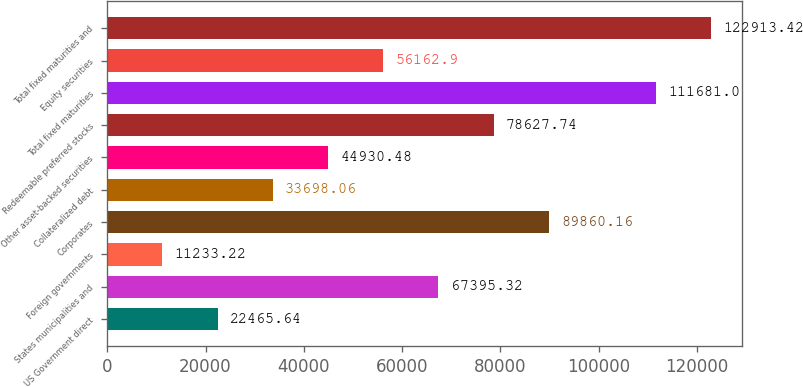<chart> <loc_0><loc_0><loc_500><loc_500><bar_chart><fcel>US Government direct<fcel>States municipalities and<fcel>Foreign governments<fcel>Corporates<fcel>Collateralized debt<fcel>Other asset-backed securities<fcel>Redeemable preferred stocks<fcel>Total fixed maturities<fcel>Equity securities<fcel>Total fixed maturities and<nl><fcel>22465.6<fcel>67395.3<fcel>11233.2<fcel>89860.2<fcel>33698.1<fcel>44930.5<fcel>78627.7<fcel>111681<fcel>56162.9<fcel>122913<nl></chart> 